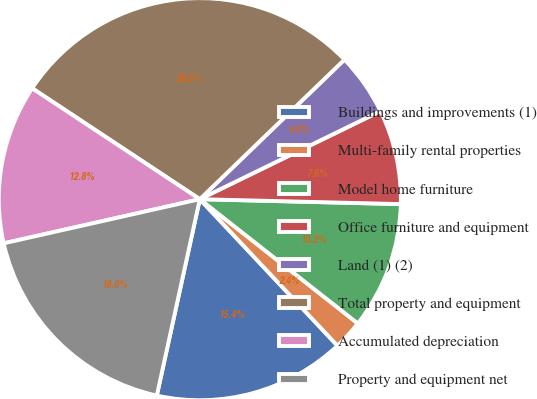Convert chart to OTSL. <chart><loc_0><loc_0><loc_500><loc_500><pie_chart><fcel>Buildings and improvements (1)<fcel>Multi-family rental properties<fcel>Model home furniture<fcel>Office furniture and equipment<fcel>Land (1) (2)<fcel>Total property and equipment<fcel>Accumulated depreciation<fcel>Property and equipment net<nl><fcel>15.44%<fcel>2.39%<fcel>10.22%<fcel>7.61%<fcel>5.0%<fcel>28.49%<fcel>12.83%<fcel>18.05%<nl></chart> 